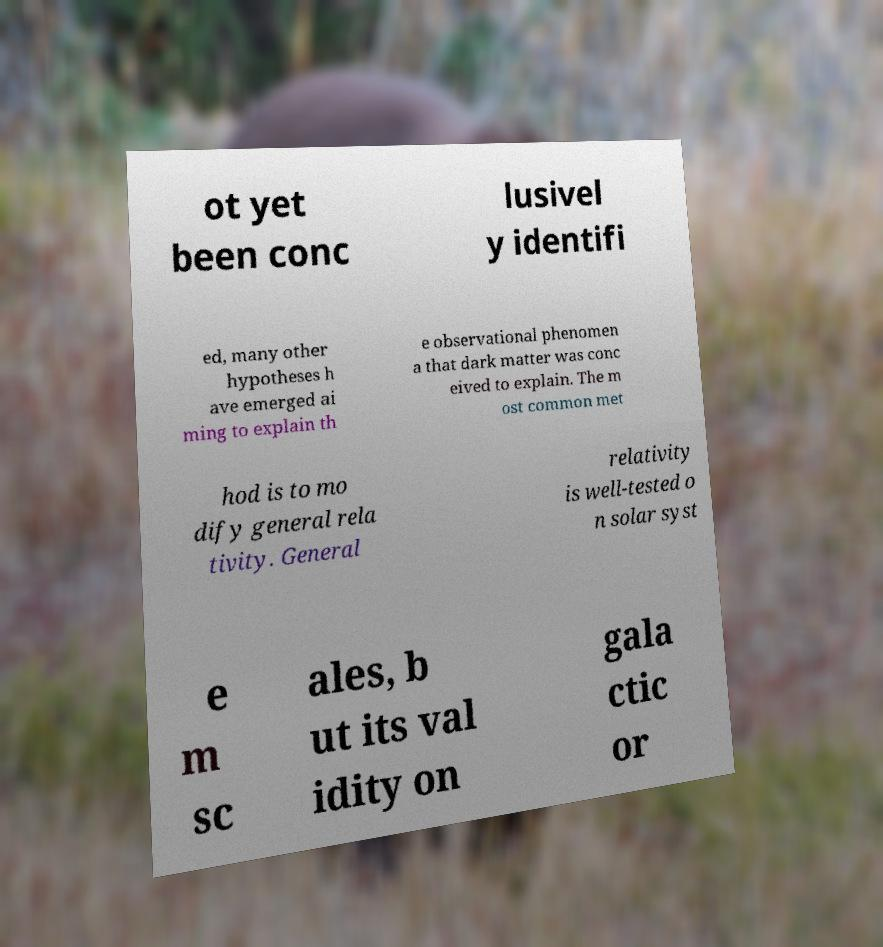Could you assist in decoding the text presented in this image and type it out clearly? ot yet been conc lusivel y identifi ed, many other hypotheses h ave emerged ai ming to explain th e observational phenomen a that dark matter was conc eived to explain. The m ost common met hod is to mo dify general rela tivity. General relativity is well-tested o n solar syst e m sc ales, b ut its val idity on gala ctic or 